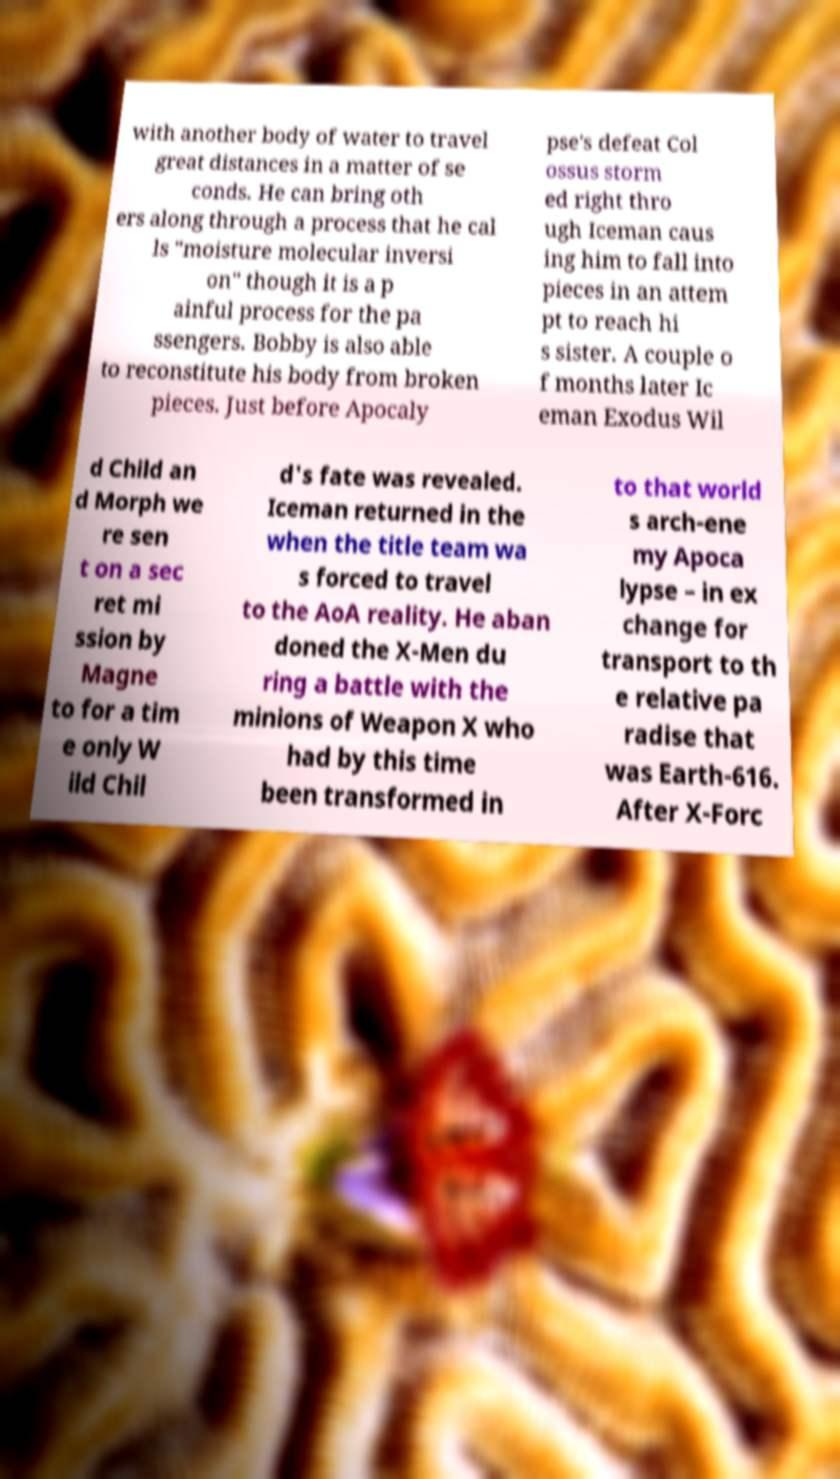Please identify and transcribe the text found in this image. with another body of water to travel great distances in a matter of se conds. He can bring oth ers along through a process that he cal ls "moisture molecular inversi on" though it is a p ainful process for the pa ssengers. Bobby is also able to reconstitute his body from broken pieces. Just before Apocaly pse's defeat Col ossus storm ed right thro ugh Iceman caus ing him to fall into pieces in an attem pt to reach hi s sister. A couple o f months later Ic eman Exodus Wil d Child an d Morph we re sen t on a sec ret mi ssion by Magne to for a tim e only W ild Chil d's fate was revealed. Iceman returned in the when the title team wa s forced to travel to the AoA reality. He aban doned the X-Men du ring a battle with the minions of Weapon X who had by this time been transformed in to that world s arch-ene my Apoca lypse – in ex change for transport to th e relative pa radise that was Earth-616. After X-Forc 